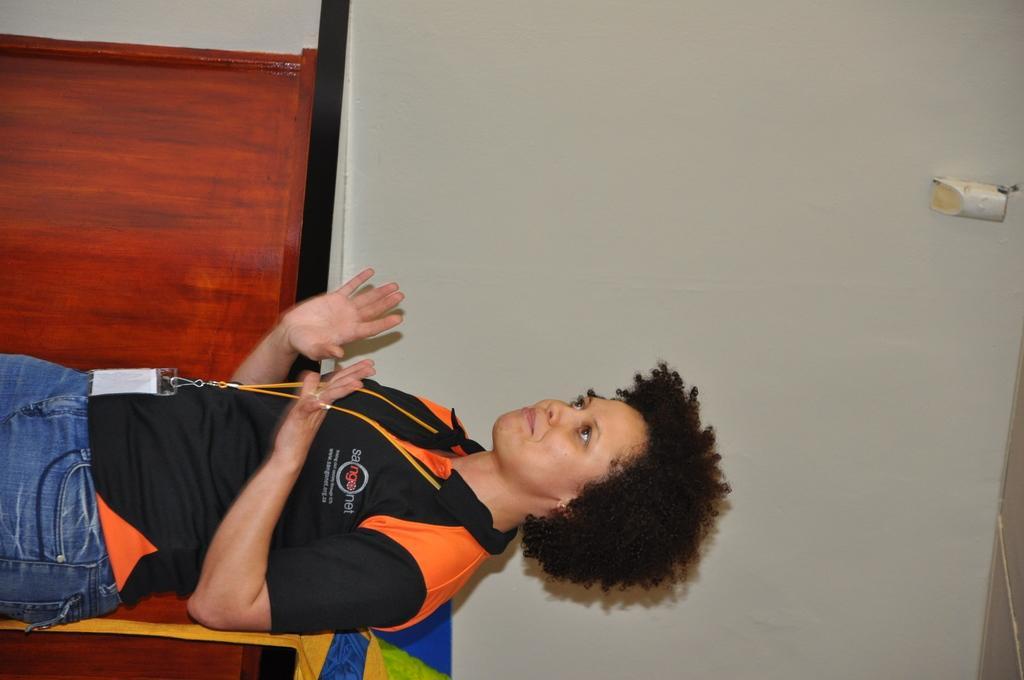Can you describe this image briefly? In this picture I can see there is a woman standing, she is wearing a black and orange shirt and she is wearing an ID card. There is a table behind her and there is an object placed on the table. 